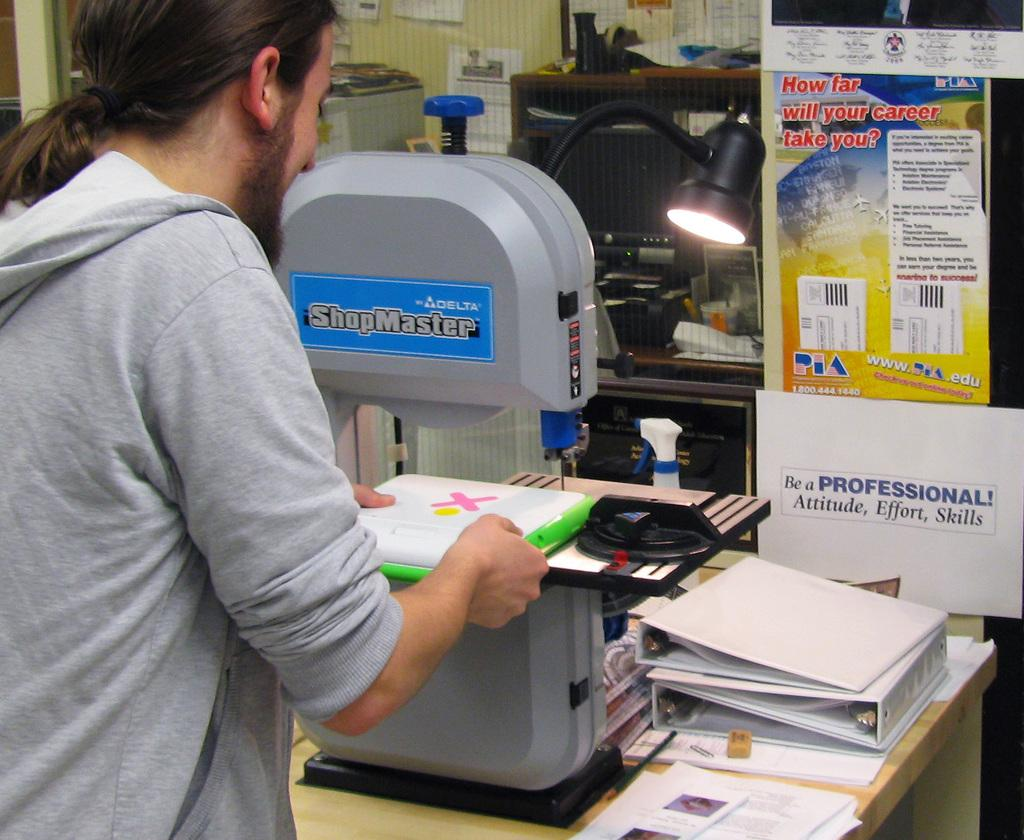<image>
Give a short and clear explanation of the subsequent image. A man wearing a gray sweatshirt is putting papers with an X on a table. 